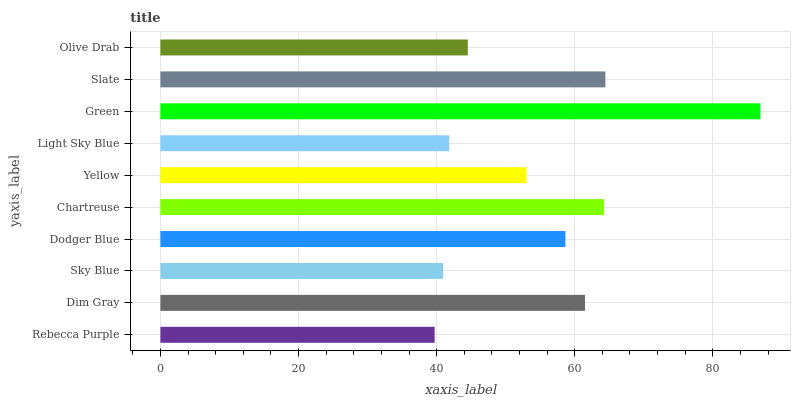Is Rebecca Purple the minimum?
Answer yes or no. Yes. Is Green the maximum?
Answer yes or no. Yes. Is Dim Gray the minimum?
Answer yes or no. No. Is Dim Gray the maximum?
Answer yes or no. No. Is Dim Gray greater than Rebecca Purple?
Answer yes or no. Yes. Is Rebecca Purple less than Dim Gray?
Answer yes or no. Yes. Is Rebecca Purple greater than Dim Gray?
Answer yes or no. No. Is Dim Gray less than Rebecca Purple?
Answer yes or no. No. Is Dodger Blue the high median?
Answer yes or no. Yes. Is Yellow the low median?
Answer yes or no. Yes. Is Yellow the high median?
Answer yes or no. No. Is Chartreuse the low median?
Answer yes or no. No. 